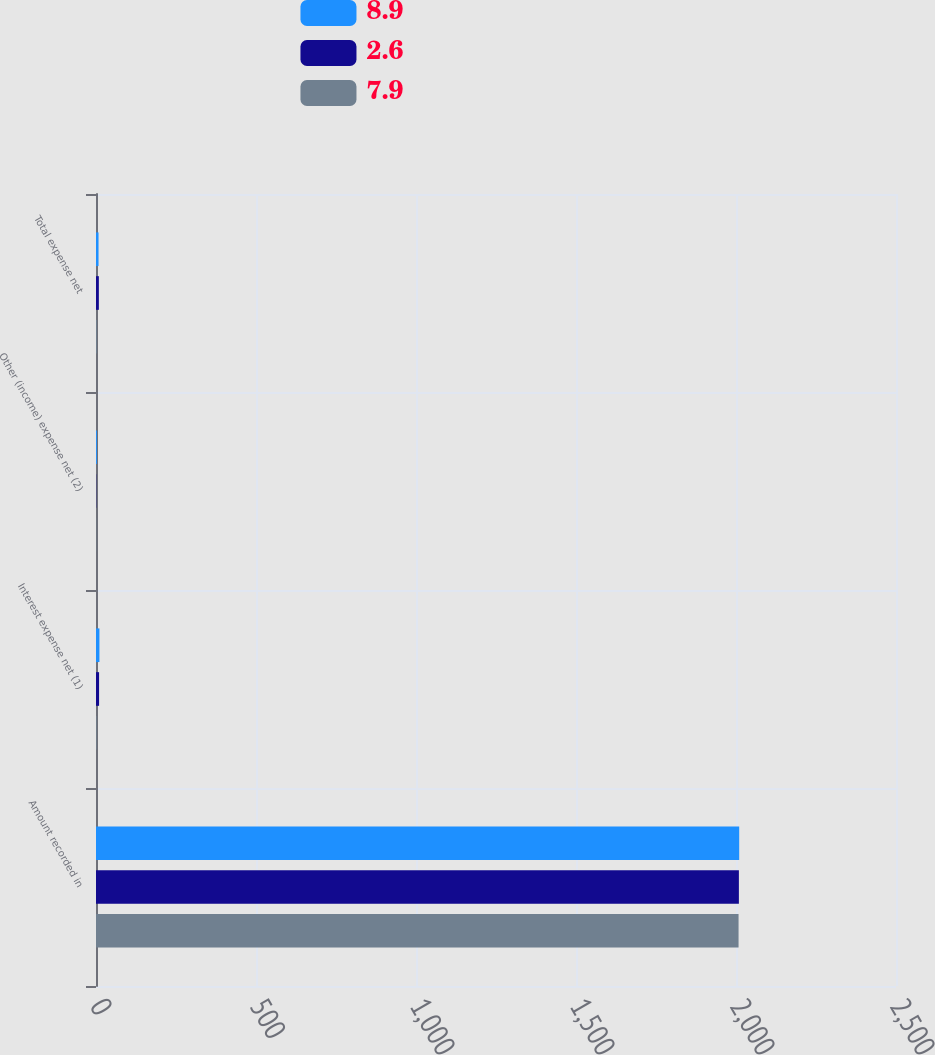<chart> <loc_0><loc_0><loc_500><loc_500><stacked_bar_chart><ecel><fcel>Amount recorded in<fcel>Interest expense net (1)<fcel>Other (income) expense net (2)<fcel>Total expense net<nl><fcel>8.9<fcel>2010<fcel>10.7<fcel>2.8<fcel>7.9<nl><fcel>2.6<fcel>2009<fcel>9.6<fcel>0.7<fcel>8.9<nl><fcel>7.9<fcel>2008<fcel>2<fcel>0.6<fcel>2.6<nl></chart> 